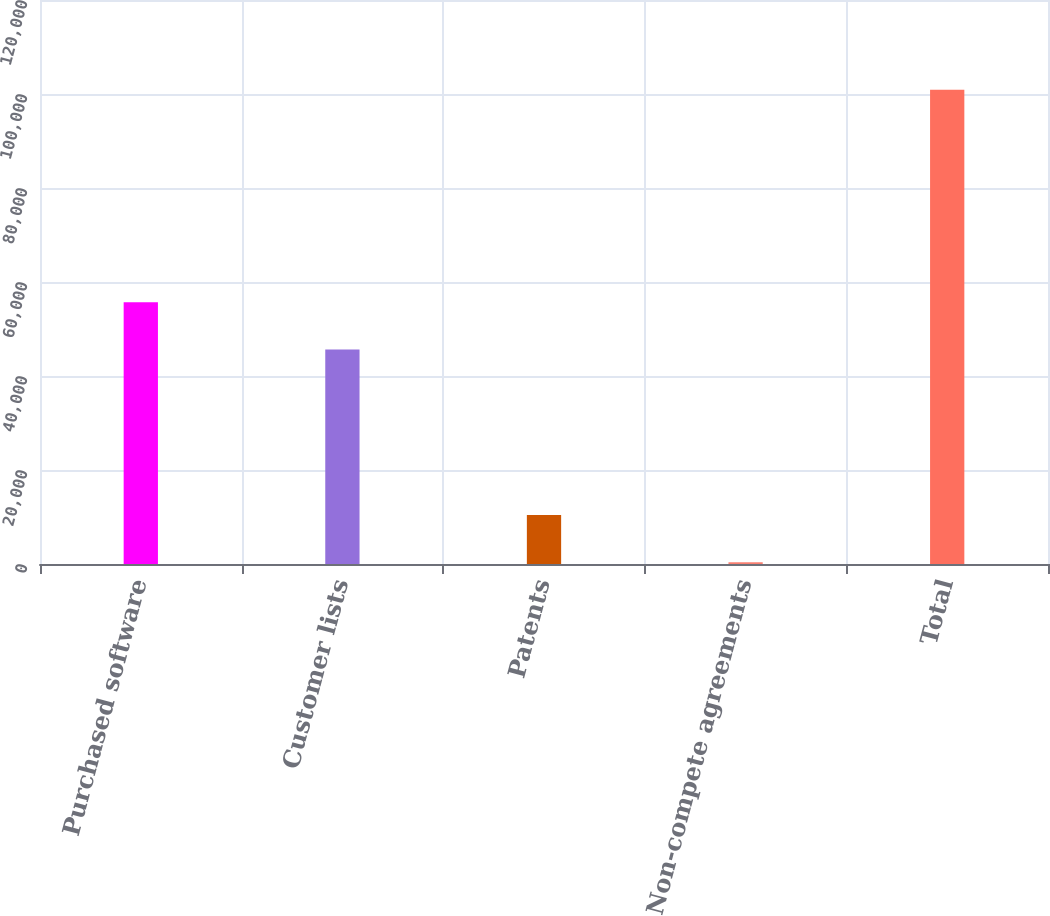<chart> <loc_0><loc_0><loc_500><loc_500><bar_chart><fcel>Purchased software<fcel>Customer lists<fcel>Patents<fcel>Non-compete agreements<fcel>Total<nl><fcel>55692.5<fcel>45642<fcel>10432.5<fcel>382<fcel>100887<nl></chart> 